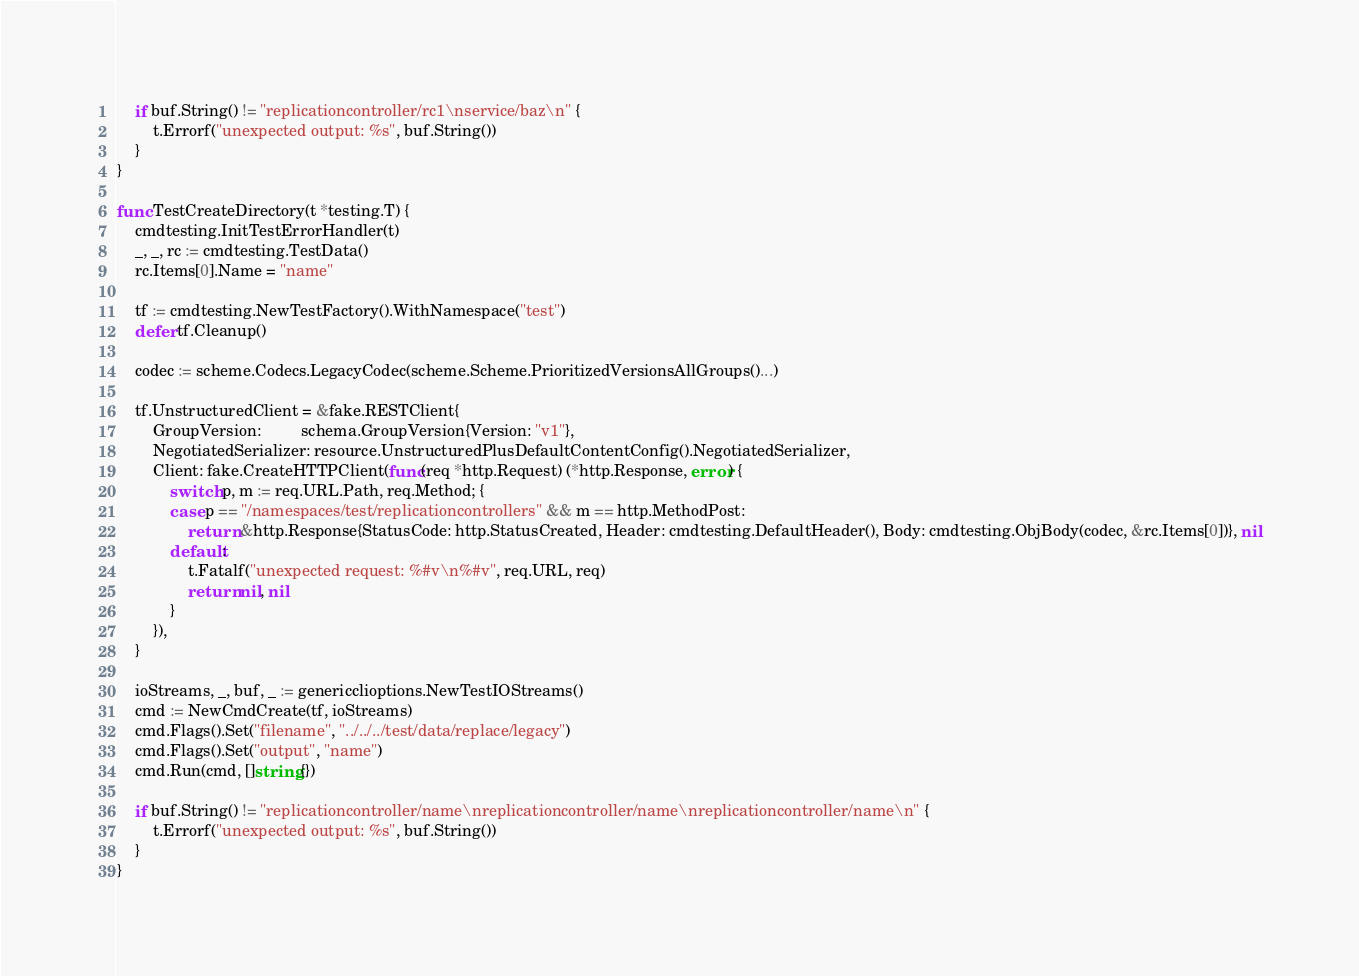Convert code to text. <code><loc_0><loc_0><loc_500><loc_500><_Go_>	if buf.String() != "replicationcontroller/rc1\nservice/baz\n" {
		t.Errorf("unexpected output: %s", buf.String())
	}
}

func TestCreateDirectory(t *testing.T) {
	cmdtesting.InitTestErrorHandler(t)
	_, _, rc := cmdtesting.TestData()
	rc.Items[0].Name = "name"

	tf := cmdtesting.NewTestFactory().WithNamespace("test")
	defer tf.Cleanup()

	codec := scheme.Codecs.LegacyCodec(scheme.Scheme.PrioritizedVersionsAllGroups()...)

	tf.UnstructuredClient = &fake.RESTClient{
		GroupVersion:         schema.GroupVersion{Version: "v1"},
		NegotiatedSerializer: resource.UnstructuredPlusDefaultContentConfig().NegotiatedSerializer,
		Client: fake.CreateHTTPClient(func(req *http.Request) (*http.Response, error) {
			switch p, m := req.URL.Path, req.Method; {
			case p == "/namespaces/test/replicationcontrollers" && m == http.MethodPost:
				return &http.Response{StatusCode: http.StatusCreated, Header: cmdtesting.DefaultHeader(), Body: cmdtesting.ObjBody(codec, &rc.Items[0])}, nil
			default:
				t.Fatalf("unexpected request: %#v\n%#v", req.URL, req)
				return nil, nil
			}
		}),
	}

	ioStreams, _, buf, _ := genericclioptions.NewTestIOStreams()
	cmd := NewCmdCreate(tf, ioStreams)
	cmd.Flags().Set("filename", "../../../test/data/replace/legacy")
	cmd.Flags().Set("output", "name")
	cmd.Run(cmd, []string{})

	if buf.String() != "replicationcontroller/name\nreplicationcontroller/name\nreplicationcontroller/name\n" {
		t.Errorf("unexpected output: %s", buf.String())
	}
}
</code> 